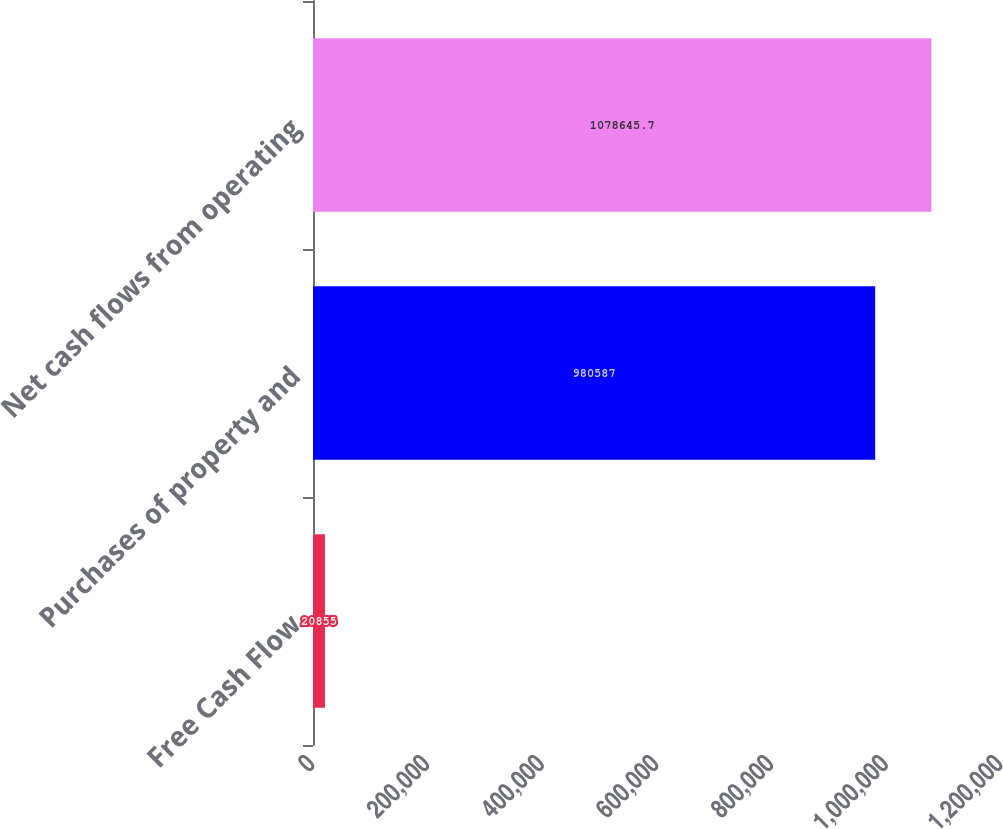<chart> <loc_0><loc_0><loc_500><loc_500><bar_chart><fcel>Free Cash Flow<fcel>Purchases of property and<fcel>Net cash flows from operating<nl><fcel>20855<fcel>980587<fcel>1.07865e+06<nl></chart> 